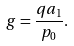<formula> <loc_0><loc_0><loc_500><loc_500>g = { \frac { q a _ { 1 } } { p _ { 0 } } } .</formula> 